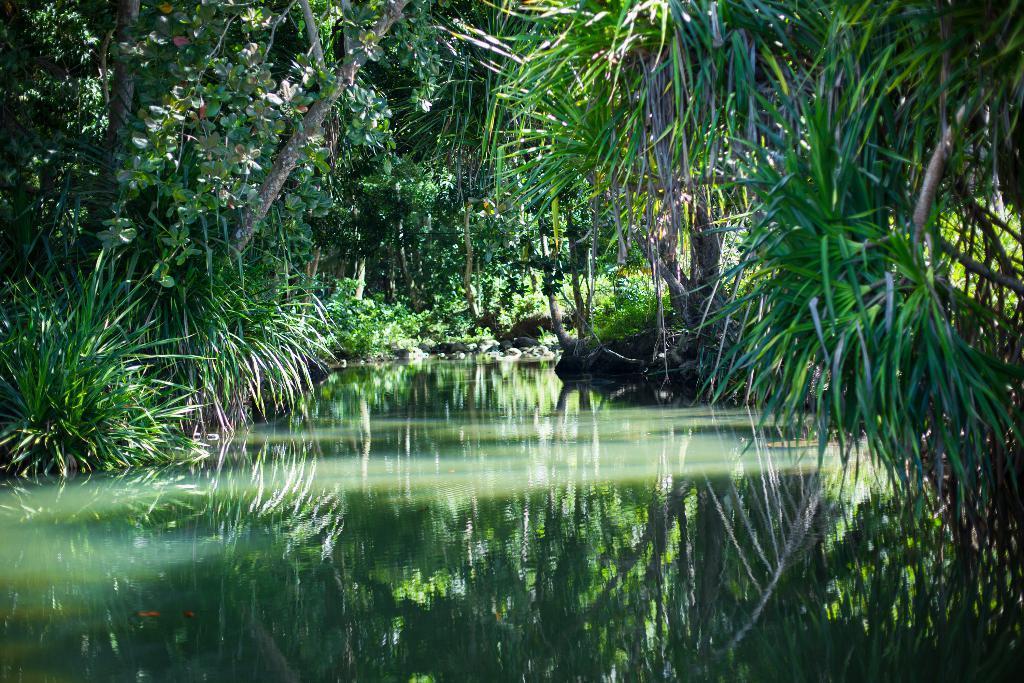In one or two sentences, can you explain what this image depicts? In the image we can see there are many trees, plants and water. In the water we can see the reflection of trees and plant. 